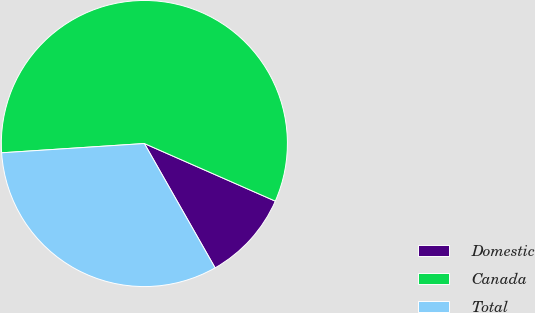Convert chart to OTSL. <chart><loc_0><loc_0><loc_500><loc_500><pie_chart><fcel>Domestic<fcel>Canada<fcel>Total<nl><fcel>10.17%<fcel>57.63%<fcel>32.2%<nl></chart> 